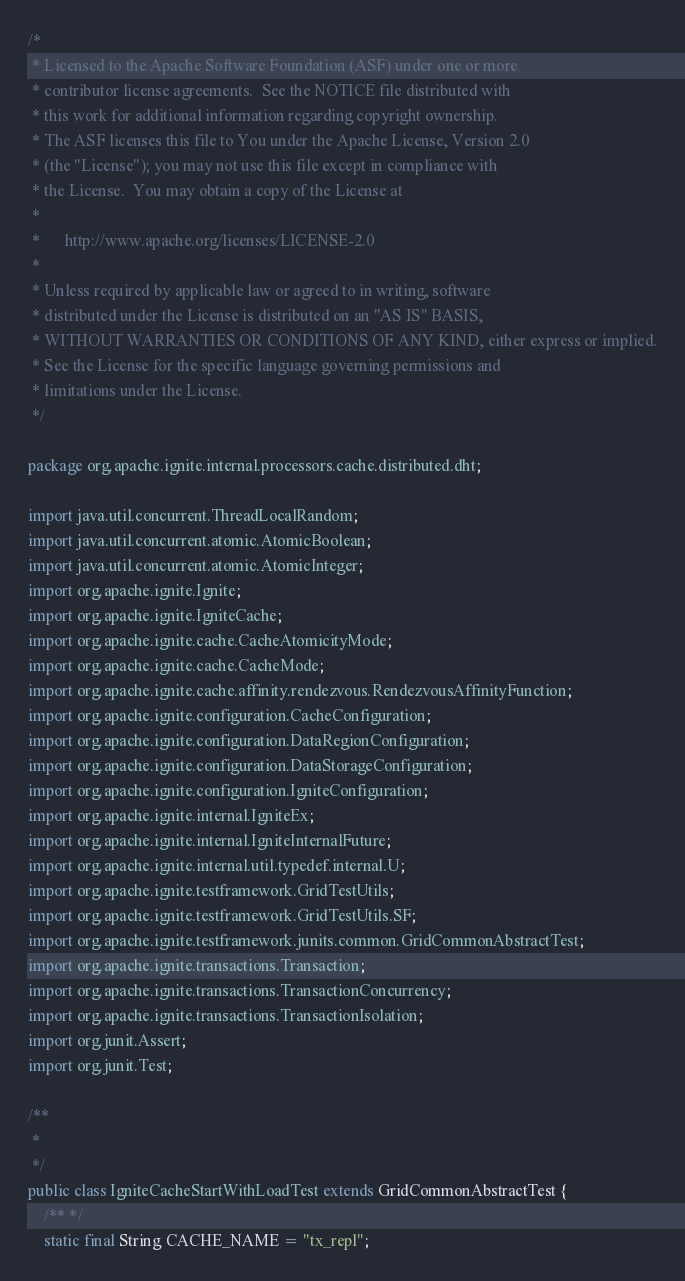<code> <loc_0><loc_0><loc_500><loc_500><_Java_>/*
 * Licensed to the Apache Software Foundation (ASF) under one or more
 * contributor license agreements.  See the NOTICE file distributed with
 * this work for additional information regarding copyright ownership.
 * The ASF licenses this file to You under the Apache License, Version 2.0
 * (the "License"); you may not use this file except in compliance with
 * the License.  You may obtain a copy of the License at
 *
 *      http://www.apache.org/licenses/LICENSE-2.0
 *
 * Unless required by applicable law or agreed to in writing, software
 * distributed under the License is distributed on an "AS IS" BASIS,
 * WITHOUT WARRANTIES OR CONDITIONS OF ANY KIND, either express or implied.
 * See the License for the specific language governing permissions and
 * limitations under the License.
 */

package org.apache.ignite.internal.processors.cache.distributed.dht;

import java.util.concurrent.ThreadLocalRandom;
import java.util.concurrent.atomic.AtomicBoolean;
import java.util.concurrent.atomic.AtomicInteger;
import org.apache.ignite.Ignite;
import org.apache.ignite.IgniteCache;
import org.apache.ignite.cache.CacheAtomicityMode;
import org.apache.ignite.cache.CacheMode;
import org.apache.ignite.cache.affinity.rendezvous.RendezvousAffinityFunction;
import org.apache.ignite.configuration.CacheConfiguration;
import org.apache.ignite.configuration.DataRegionConfiguration;
import org.apache.ignite.configuration.DataStorageConfiguration;
import org.apache.ignite.configuration.IgniteConfiguration;
import org.apache.ignite.internal.IgniteEx;
import org.apache.ignite.internal.IgniteInternalFuture;
import org.apache.ignite.internal.util.typedef.internal.U;
import org.apache.ignite.testframework.GridTestUtils;
import org.apache.ignite.testframework.GridTestUtils.SF;
import org.apache.ignite.testframework.junits.common.GridCommonAbstractTest;
import org.apache.ignite.transactions.Transaction;
import org.apache.ignite.transactions.TransactionConcurrency;
import org.apache.ignite.transactions.TransactionIsolation;
import org.junit.Assert;
import org.junit.Test;

/**
 *
 */
public class IgniteCacheStartWithLoadTest extends GridCommonAbstractTest {
    /** */
    static final String CACHE_NAME = "tx_repl";
</code> 